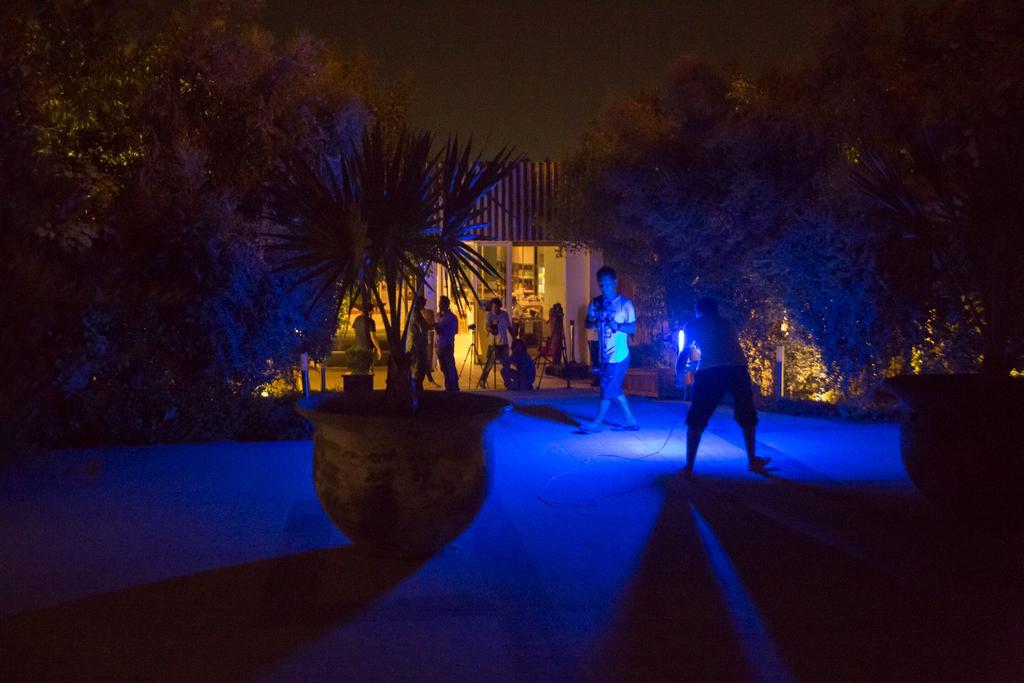Please provide a concise description of this image. In this picture there are people and we can see plants with pots, trees, house and stands. In the background of the image we can see the sky. 